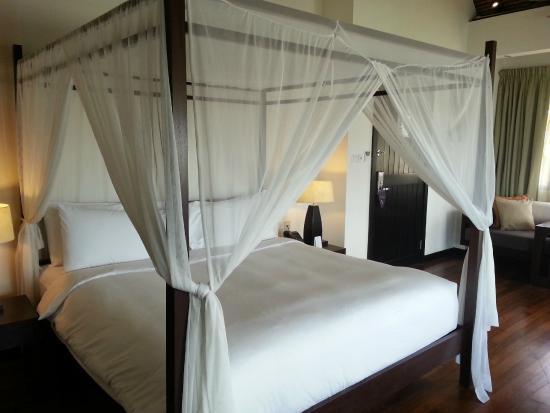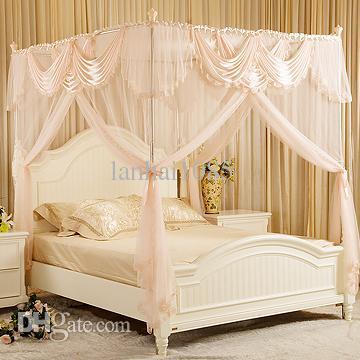The first image is the image on the left, the second image is the image on the right. Considering the images on both sides, is "Exactly one bed has corner posts." valid? Answer yes or no. No. The first image is the image on the left, the second image is the image on the right. For the images shown, is this caption "The bed in the image on the right is covered by a curved tent." true? Answer yes or no. No. 